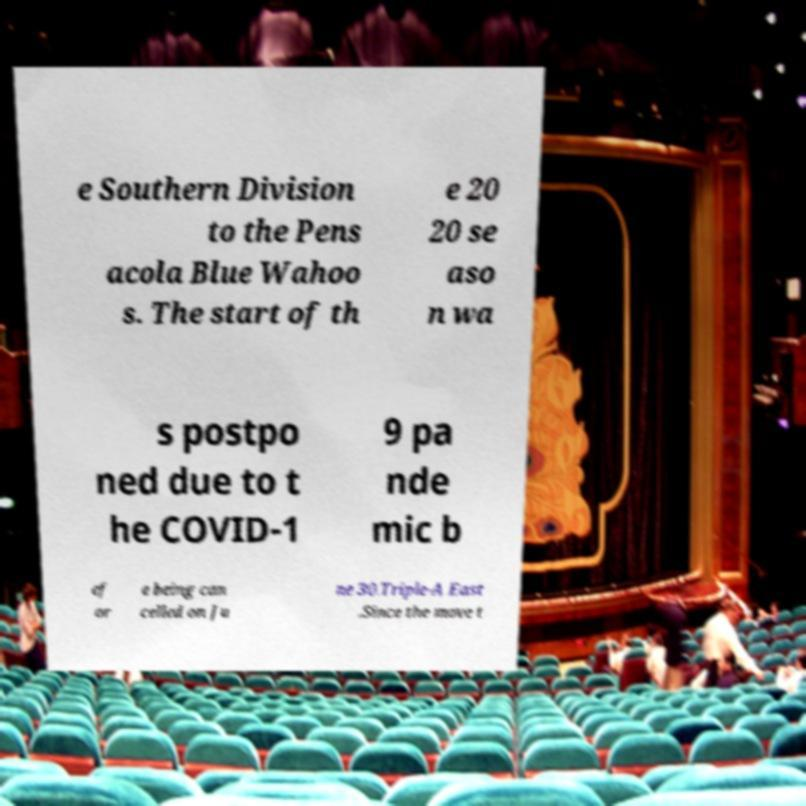For documentation purposes, I need the text within this image transcribed. Could you provide that? e Southern Division to the Pens acola Blue Wahoo s. The start of th e 20 20 se aso n wa s postpo ned due to t he COVID-1 9 pa nde mic b ef or e being can celled on Ju ne 30.Triple-A East .Since the move t 